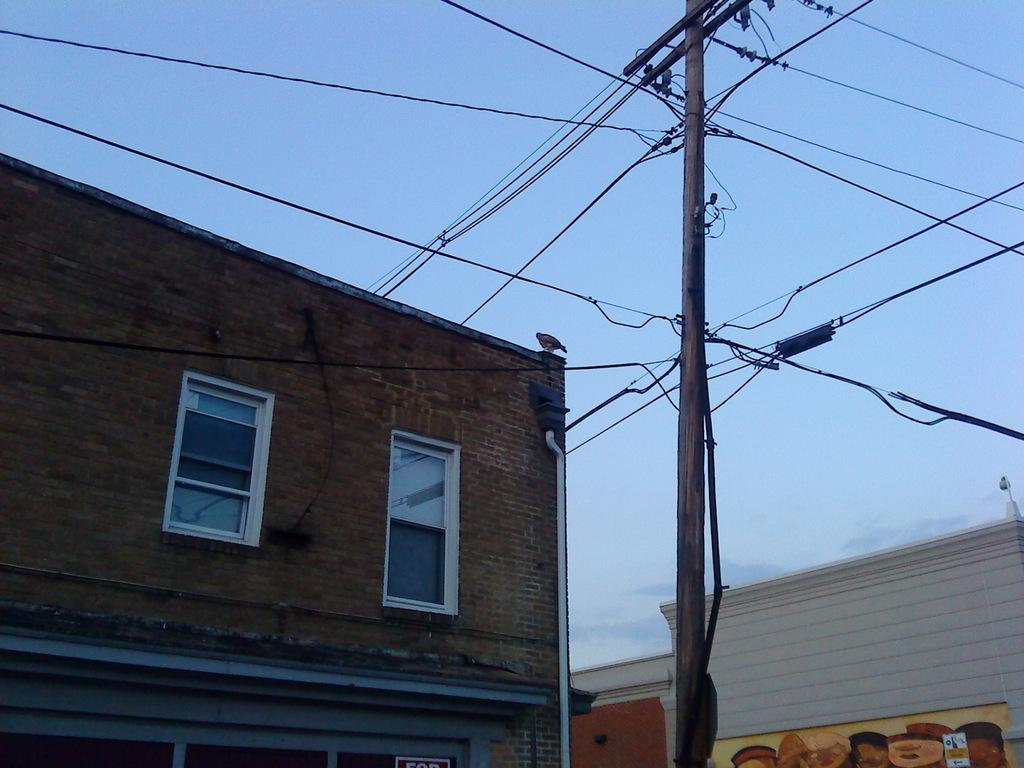What type of structures are present in the image? There are houses in the image. What else can be seen in the image besides the houses? There is an electric pole and wires visible in the image. What is the condition of the sky in the image? The sky is clear at the top of the image. Can you tell me what type of music the woman is playing on the electric pole in the image? There is no woman present in the image, and the electric pole is not associated with any musical activity. 